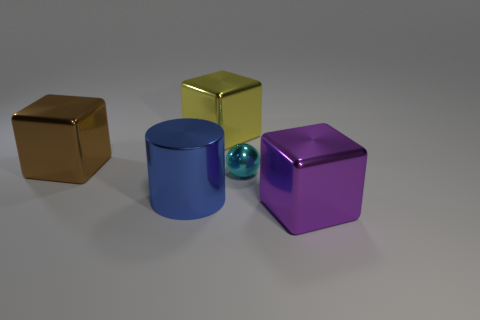There is a metallic object that is on the right side of the large yellow object and behind the big metal cylinder; what shape is it?
Give a very brief answer. Sphere. What material is the cylinder?
Provide a short and direct response. Metal. What number of blocks are small cyan things or purple shiny objects?
Your response must be concise. 1. Is the big blue thing made of the same material as the small cyan sphere?
Ensure brevity in your answer.  Yes. There is a brown metal object that is the same shape as the large purple metallic thing; what is its size?
Keep it short and to the point. Large. There is a block that is both to the left of the tiny ball and on the right side of the large brown metal object; what material is it?
Give a very brief answer. Metal. Are there an equal number of big metal cubes in front of the cyan shiny sphere and cyan metallic spheres?
Your answer should be very brief. Yes. How many objects are things behind the cyan metal sphere or metallic cylinders?
Provide a succinct answer. 3. There is a metal block on the right side of the small cyan sphere; does it have the same color as the small sphere?
Provide a short and direct response. No. There is a metallic block that is on the right side of the yellow block; what size is it?
Make the answer very short. Large. 